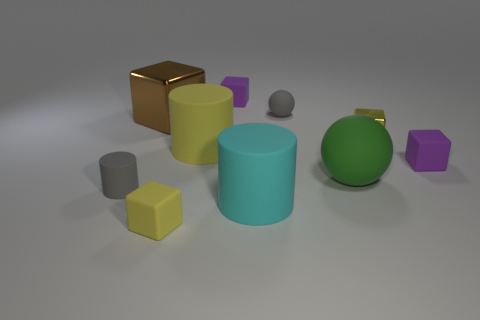Subtract all tiny gray matte cylinders. How many cylinders are left? 2 Add 1 purple rubber cubes. How many purple rubber cubes are left? 3 Add 3 green spheres. How many green spheres exist? 4 Subtract all yellow blocks. How many blocks are left? 3 Subtract 2 purple cubes. How many objects are left? 8 Subtract all balls. How many objects are left? 8 Subtract 2 balls. How many balls are left? 0 Subtract all gray cylinders. Subtract all gray spheres. How many cylinders are left? 2 Subtract all red spheres. How many red cylinders are left? 0 Subtract all small cyan objects. Subtract all big brown things. How many objects are left? 9 